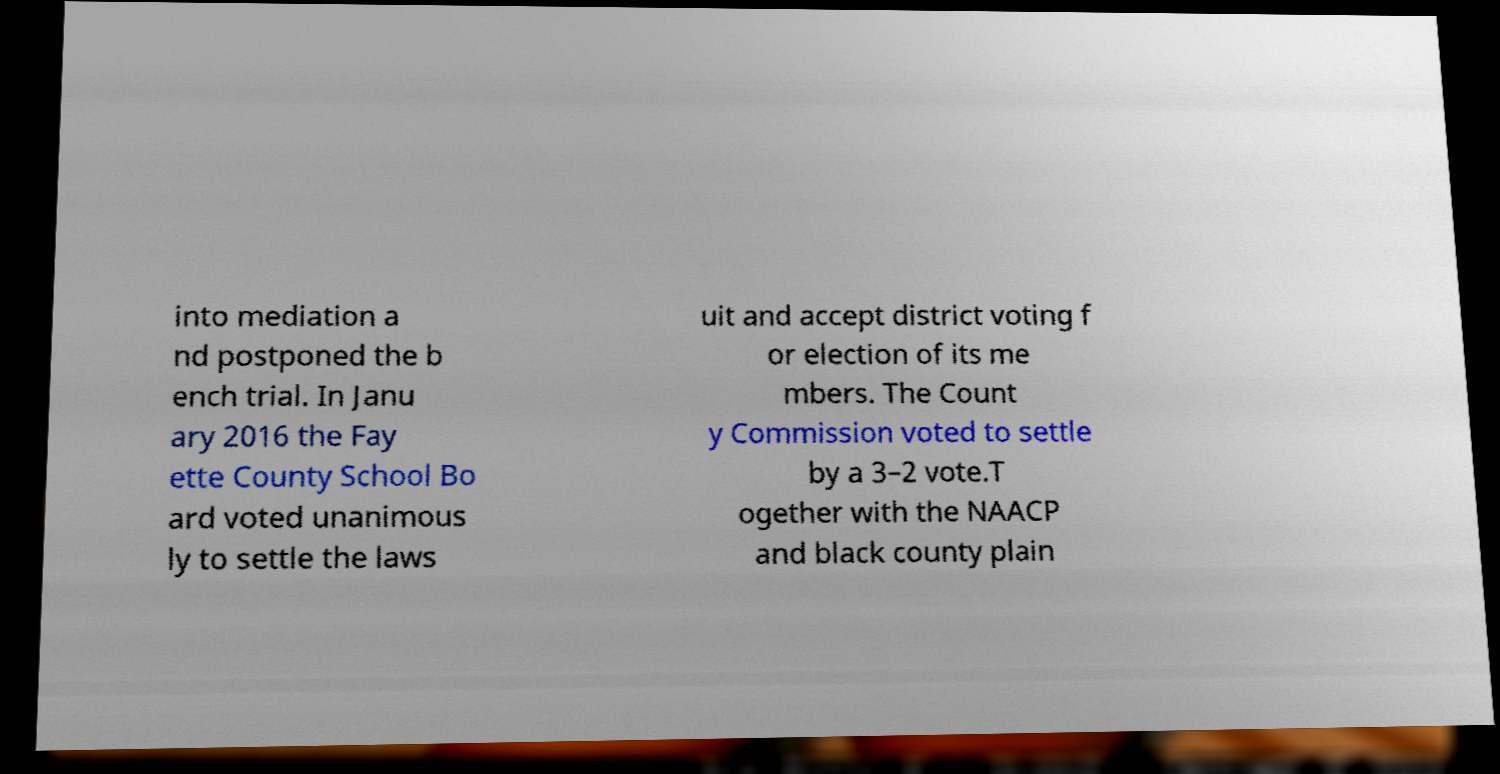Can you accurately transcribe the text from the provided image for me? into mediation a nd postponed the b ench trial. In Janu ary 2016 the Fay ette County School Bo ard voted unanimous ly to settle the laws uit and accept district voting f or election of its me mbers. The Count y Commission voted to settle by a 3–2 vote.T ogether with the NAACP and black county plain 